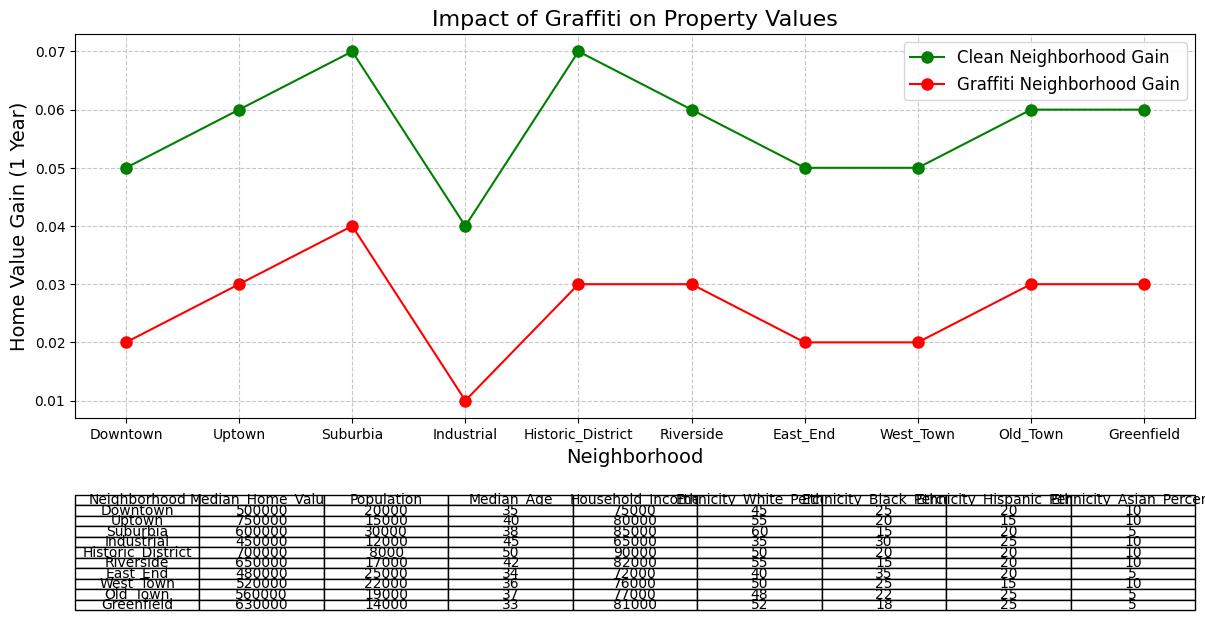What is the percentage difference in average home value gain between a clean neighborhood and a graffiti-affected neighborhood for 'Industrial'? To calculate the percentage difference, subtract the graffiti-affected gain (0.01) from the clean gain (0.04) and then divide this difference by the graffiti-affected gain. Finally, multiply by 100 to get the percentage: ((0.04 - 0.01) / 0.01) * 100.
Answer: 300% Which neighborhood has the highest median home value? Identify the highest value in the 'Median_Home_Value' column by comparing all listed neighborhoods. The Historic District has the highest median home value of 700000.
Answer: Historic District What is the overall average home value gain for neighborhoods without graffiti? Sum all the values in the 'Average_Home_Value_Gain_1_Year_Clean' column (0.05+0.06+0.07+0.04+0.07+0.06+0.05+0.05+0.06+0.06) and divide by the number of neighborhoods (10).
Answer: 0.057 How much higher is the median home value of Riverside compared to East End? Subtract the median home value of East End (480000) from that of Riverside (650000) to find the difference.
Answer: 170000 Which neighborhood has the lowest average home value gain in a graffiti-affected environment? Look for the smallest value in the 'Average_Home_Value_Gain_1_Year_Graffiti' column. The Industrial neighborhood has the lowest gain of 0.01.
Answer: Industrial How does household income in Downtown compare to Uptown? Compare the household income values for both neighborhoods. Downtown has 75000, while Uptown has 80000. Thus, Uptown's income is higher.
Answer: Uptown's income is higher Which two neighborhoods have the closest average home value gain in clean neighborhoods? Identify the two closest values in the 'Average_Home_Value_Gain_1_Year_Clean' column. Both West Town and East End have a gain of 0.05, so they are equal.
Answer: West Town and East End What is the visual difference in the plot lines representing clean and graffiti-affected neighborhoods? Describe the color and pattern differences. Clean neighborhoods are represented by a green line with circle markers, while graffiti-affected neighborhoods are represented by a red line with circle markers.
Answer: Green and red lines with circle markers What is the combined population of Suburbia and Industrial? Add the population of Suburbia (30000) to that of Industrial (12000).
Answer: 42000 Does the Ethnicity_Black_Percent in East End exceed that in Riverside? Compare the values from both neighborhoods. East End has 35% while Riverside has 15%. Thus, East End's percentage is higher.
Answer: Yes, East End's percentage is higher 